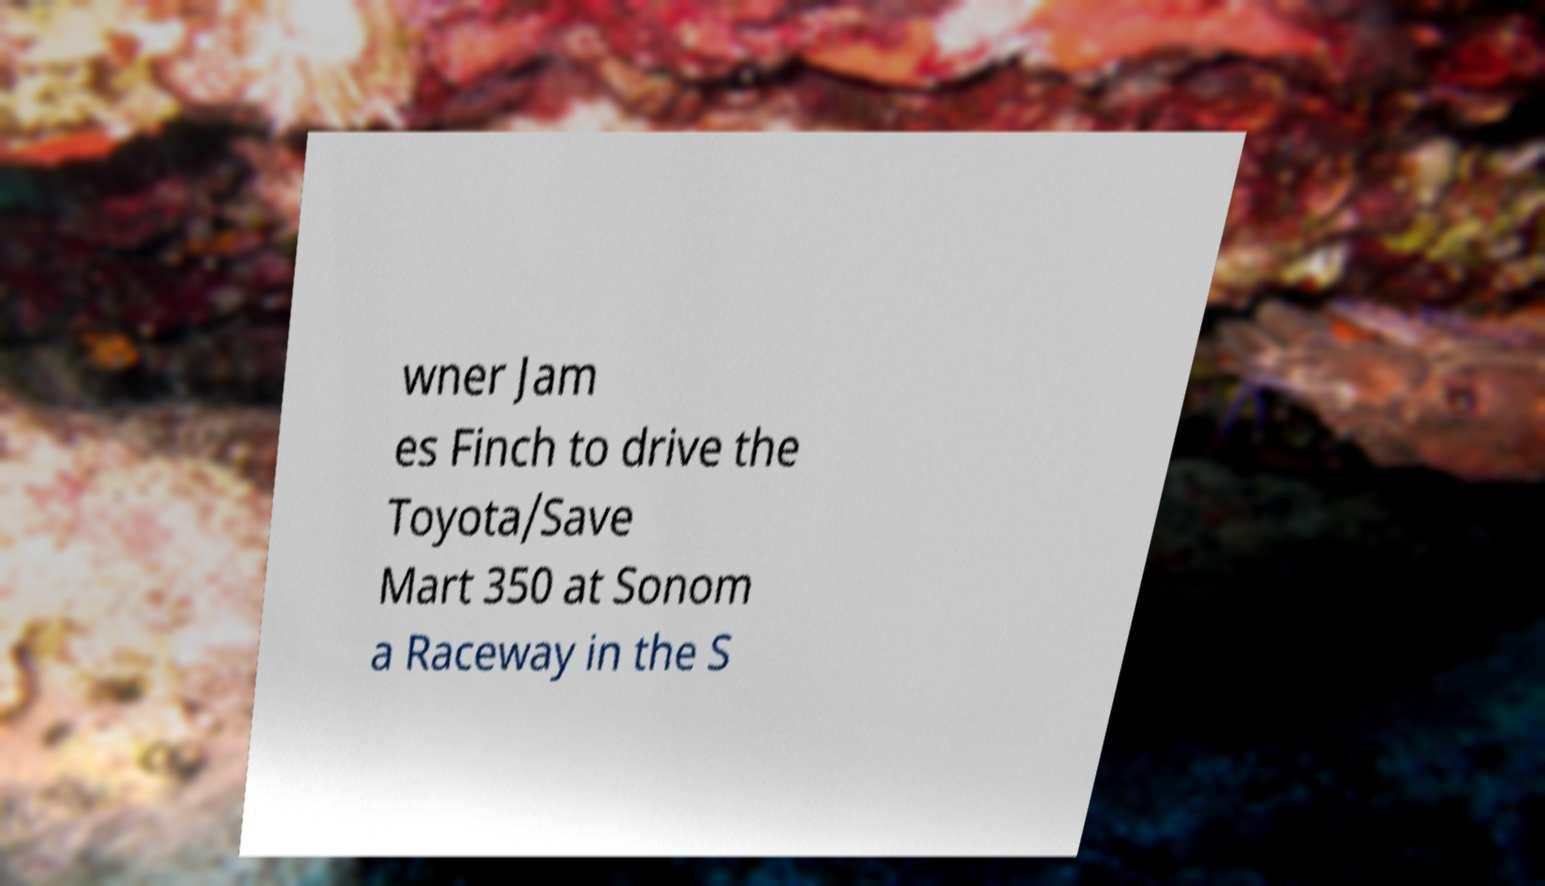Could you assist in decoding the text presented in this image and type it out clearly? wner Jam es Finch to drive the Toyota/Save Mart 350 at Sonom a Raceway in the S 